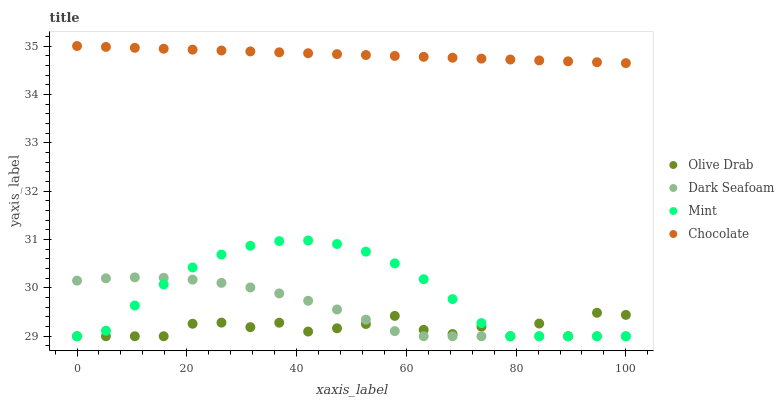Does Olive Drab have the minimum area under the curve?
Answer yes or no. Yes. Does Chocolate have the maximum area under the curve?
Answer yes or no. Yes. Does Mint have the minimum area under the curve?
Answer yes or no. No. Does Mint have the maximum area under the curve?
Answer yes or no. No. Is Chocolate the smoothest?
Answer yes or no. Yes. Is Olive Drab the roughest?
Answer yes or no. Yes. Is Mint the smoothest?
Answer yes or no. No. Is Mint the roughest?
Answer yes or no. No. Does Dark Seafoam have the lowest value?
Answer yes or no. Yes. Does Chocolate have the lowest value?
Answer yes or no. No. Does Chocolate have the highest value?
Answer yes or no. Yes. Does Mint have the highest value?
Answer yes or no. No. Is Dark Seafoam less than Chocolate?
Answer yes or no. Yes. Is Chocolate greater than Mint?
Answer yes or no. Yes. Does Mint intersect Olive Drab?
Answer yes or no. Yes. Is Mint less than Olive Drab?
Answer yes or no. No. Is Mint greater than Olive Drab?
Answer yes or no. No. Does Dark Seafoam intersect Chocolate?
Answer yes or no. No. 